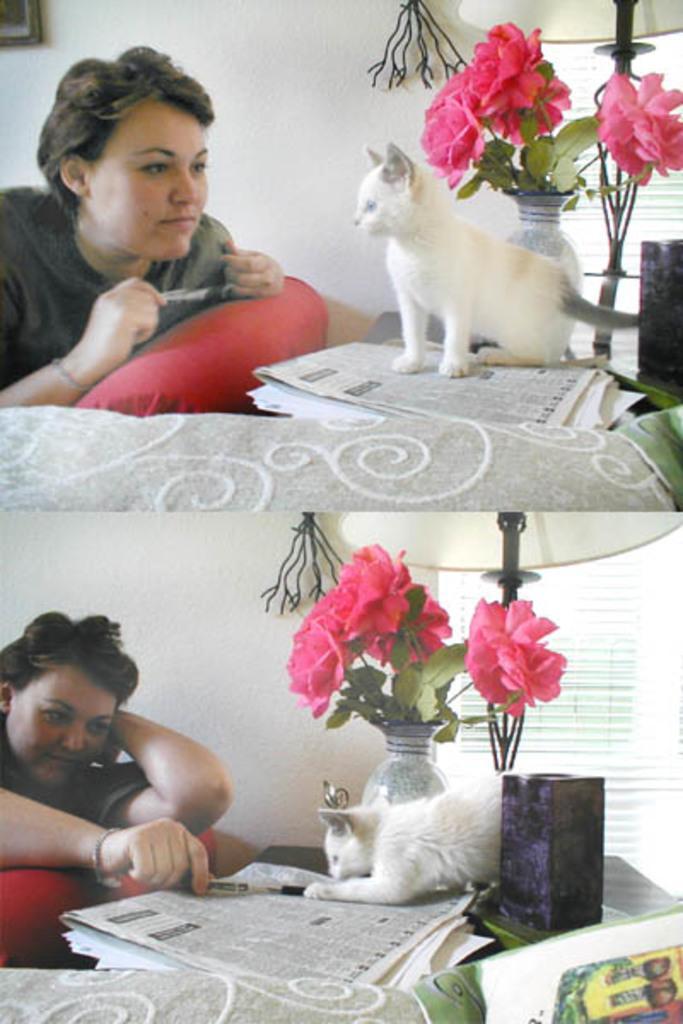In one or two sentences, can you explain what this image depicts? In this picture there is a lady at the left side of the image and there is a cat in front of her which is placed on a table and there is a flower pot near the cat, and again in second album there is a lady who is touching the cat with her pen, there is a flower pot near the cat. 